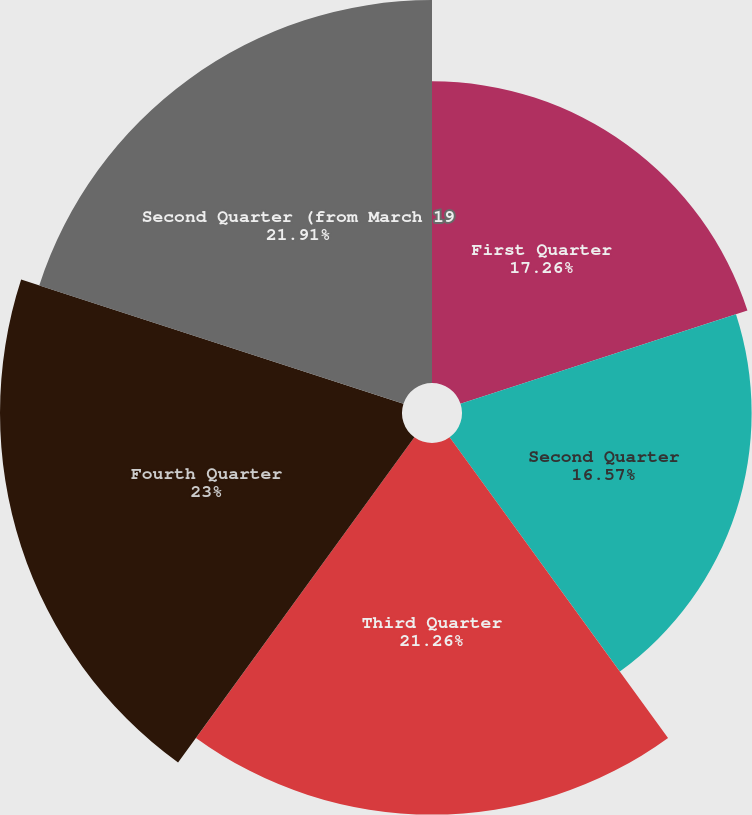Convert chart to OTSL. <chart><loc_0><loc_0><loc_500><loc_500><pie_chart><fcel>First Quarter<fcel>Second Quarter<fcel>Third Quarter<fcel>Fourth Quarter<fcel>Second Quarter (from March 19<nl><fcel>17.26%<fcel>16.57%<fcel>21.26%<fcel>23.0%<fcel>21.91%<nl></chart> 